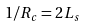Convert formula to latex. <formula><loc_0><loc_0><loc_500><loc_500>1 / R _ { c } = 2 L _ { s }</formula> 